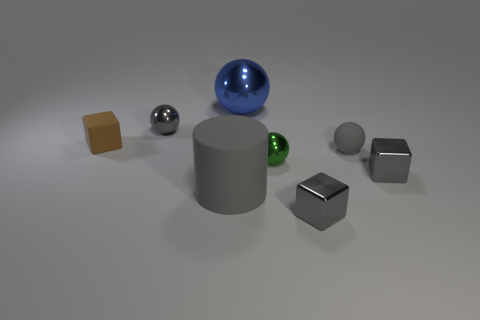Subtract all tiny matte spheres. How many spheres are left? 3 Add 2 small gray objects. How many objects exist? 10 Subtract all brown cubes. How many cubes are left? 2 Subtract all cylinders. How many objects are left? 7 Subtract all green cylinders. How many gray blocks are left? 2 Add 7 tiny rubber blocks. How many tiny rubber blocks exist? 8 Subtract 0 blue cylinders. How many objects are left? 8 Subtract 2 balls. How many balls are left? 2 Subtract all brown cylinders. Subtract all red cubes. How many cylinders are left? 1 Subtract all big brown metallic things. Subtract all tiny green metallic balls. How many objects are left? 7 